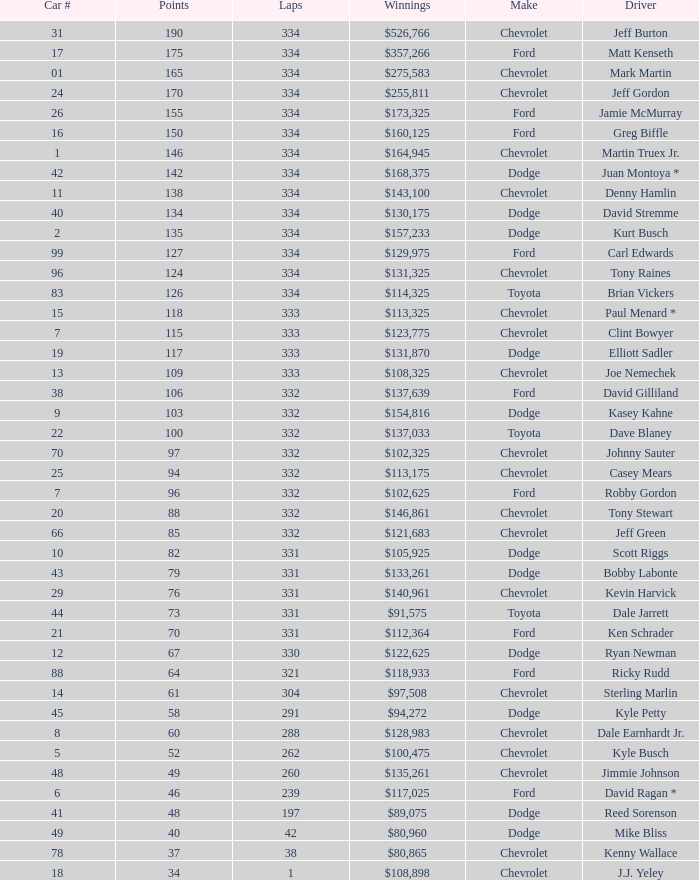How many total laps did the Chevrolet that won $97,508 make? 1.0. 